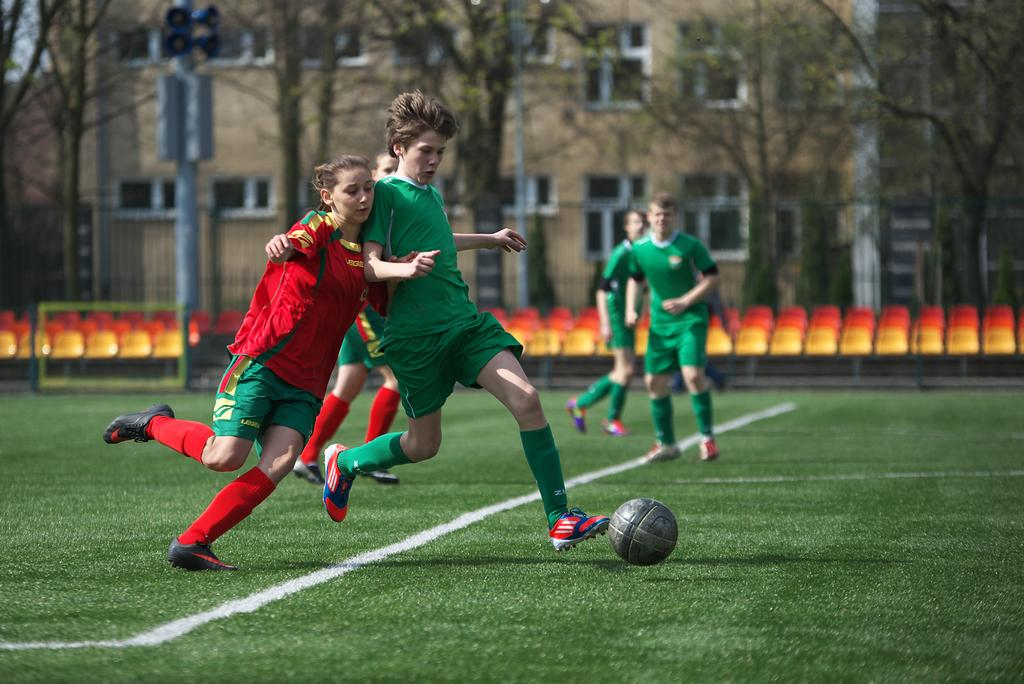What sport are the players engaged in within the image? The players are playing football in the image. What can be seen in the background of the image? Trees and buildings are visible in the image. Are there any facilities for spectators in the image? Yes, there are chairs for the audience in the image. What is the color of the football field? The field is green. What type of pizzas are being served to the players during the game in the image? There is no mention of pizzas or any food being served in the image. The focus is on the football game and the surrounding environment. 